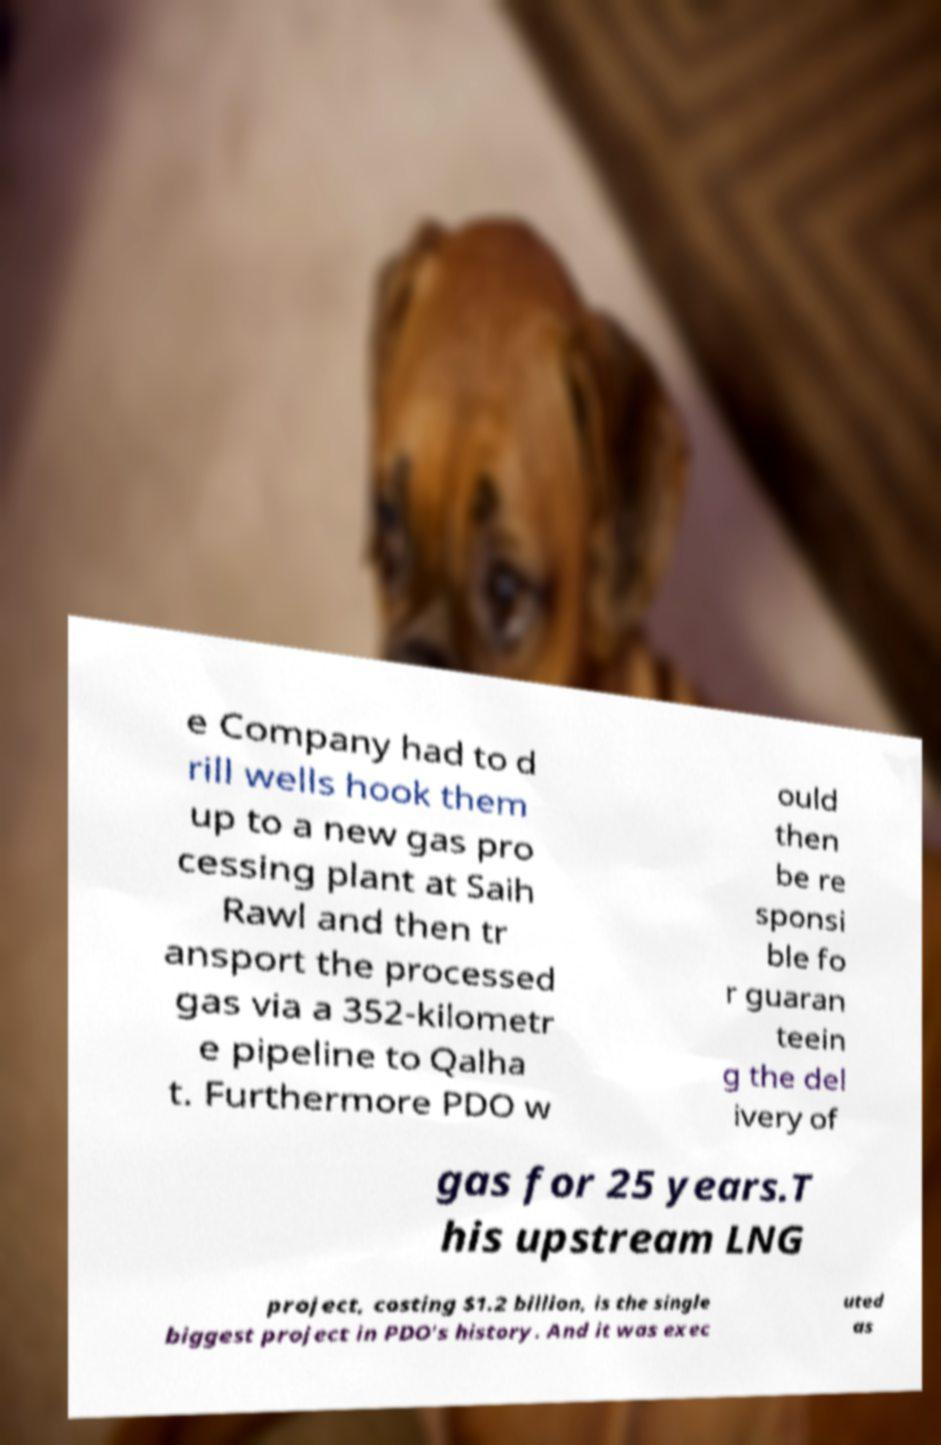What messages or text are displayed in this image? I need them in a readable, typed format. e Company had to d rill wells hook them up to a new gas pro cessing plant at Saih Rawl and then tr ansport the processed gas via a 352-kilometr e pipeline to Qalha t. Furthermore PDO w ould then be re sponsi ble fo r guaran teein g the del ivery of gas for 25 years.T his upstream LNG project, costing $1.2 billion, is the single biggest project in PDO's history. And it was exec uted as 